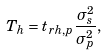Convert formula to latex. <formula><loc_0><loc_0><loc_500><loc_500>T _ { h } = t _ { r h , p } \frac { \sigma _ { s } ^ { 2 } } { \sigma _ { p } ^ { 2 } } ,</formula> 